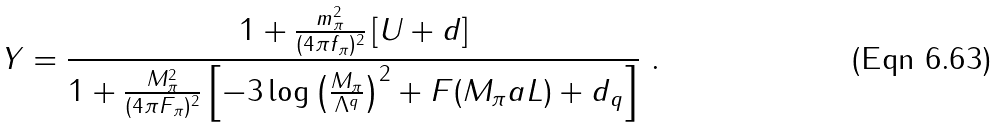<formula> <loc_0><loc_0><loc_500><loc_500>Y = \frac { 1 + \frac { m _ { \pi } ^ { 2 } } { ( 4 \pi f _ { \pi } ) ^ { 2 } } \left [ U + d \right ] } { 1 + \frac { M _ { \pi } ^ { 2 } } { ( 4 \pi F _ { \pi } ) ^ { 2 } } \left [ - 3 \log \left ( \frac { M _ { \pi } } { \Lambda ^ { q } } \right ) ^ { 2 } + F ( M _ { \pi } a L ) + d _ { q } \right ] } \ .</formula> 